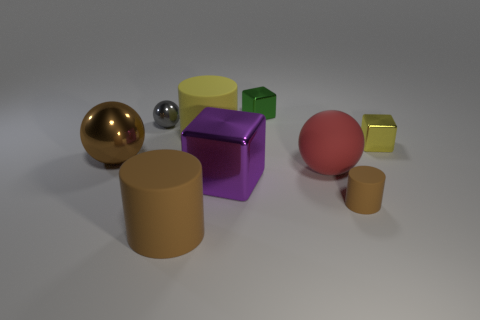Add 1 big brown spheres. How many objects exist? 10 Subtract all purple shiny cubes. How many cubes are left? 2 Subtract all blocks. How many objects are left? 6 Subtract 0 red blocks. How many objects are left? 9 Subtract all red matte objects. Subtract all brown things. How many objects are left? 5 Add 7 gray metallic spheres. How many gray metallic spheres are left? 8 Add 6 yellow rubber things. How many yellow rubber things exist? 7 